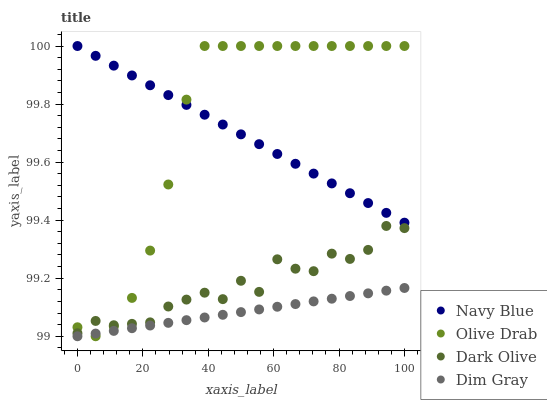Does Dim Gray have the minimum area under the curve?
Answer yes or no. Yes. Does Olive Drab have the maximum area under the curve?
Answer yes or no. Yes. Does Dark Olive have the minimum area under the curve?
Answer yes or no. No. Does Dark Olive have the maximum area under the curve?
Answer yes or no. No. Is Dim Gray the smoothest?
Answer yes or no. Yes. Is Dark Olive the roughest?
Answer yes or no. Yes. Is Dark Olive the smoothest?
Answer yes or no. No. Is Dim Gray the roughest?
Answer yes or no. No. Does Dim Gray have the lowest value?
Answer yes or no. Yes. Does Dark Olive have the lowest value?
Answer yes or no. No. Does Olive Drab have the highest value?
Answer yes or no. Yes. Does Dark Olive have the highest value?
Answer yes or no. No. Is Dim Gray less than Dark Olive?
Answer yes or no. Yes. Is Dark Olive greater than Dim Gray?
Answer yes or no. Yes. Does Olive Drab intersect Navy Blue?
Answer yes or no. Yes. Is Olive Drab less than Navy Blue?
Answer yes or no. No. Is Olive Drab greater than Navy Blue?
Answer yes or no. No. Does Dim Gray intersect Dark Olive?
Answer yes or no. No. 